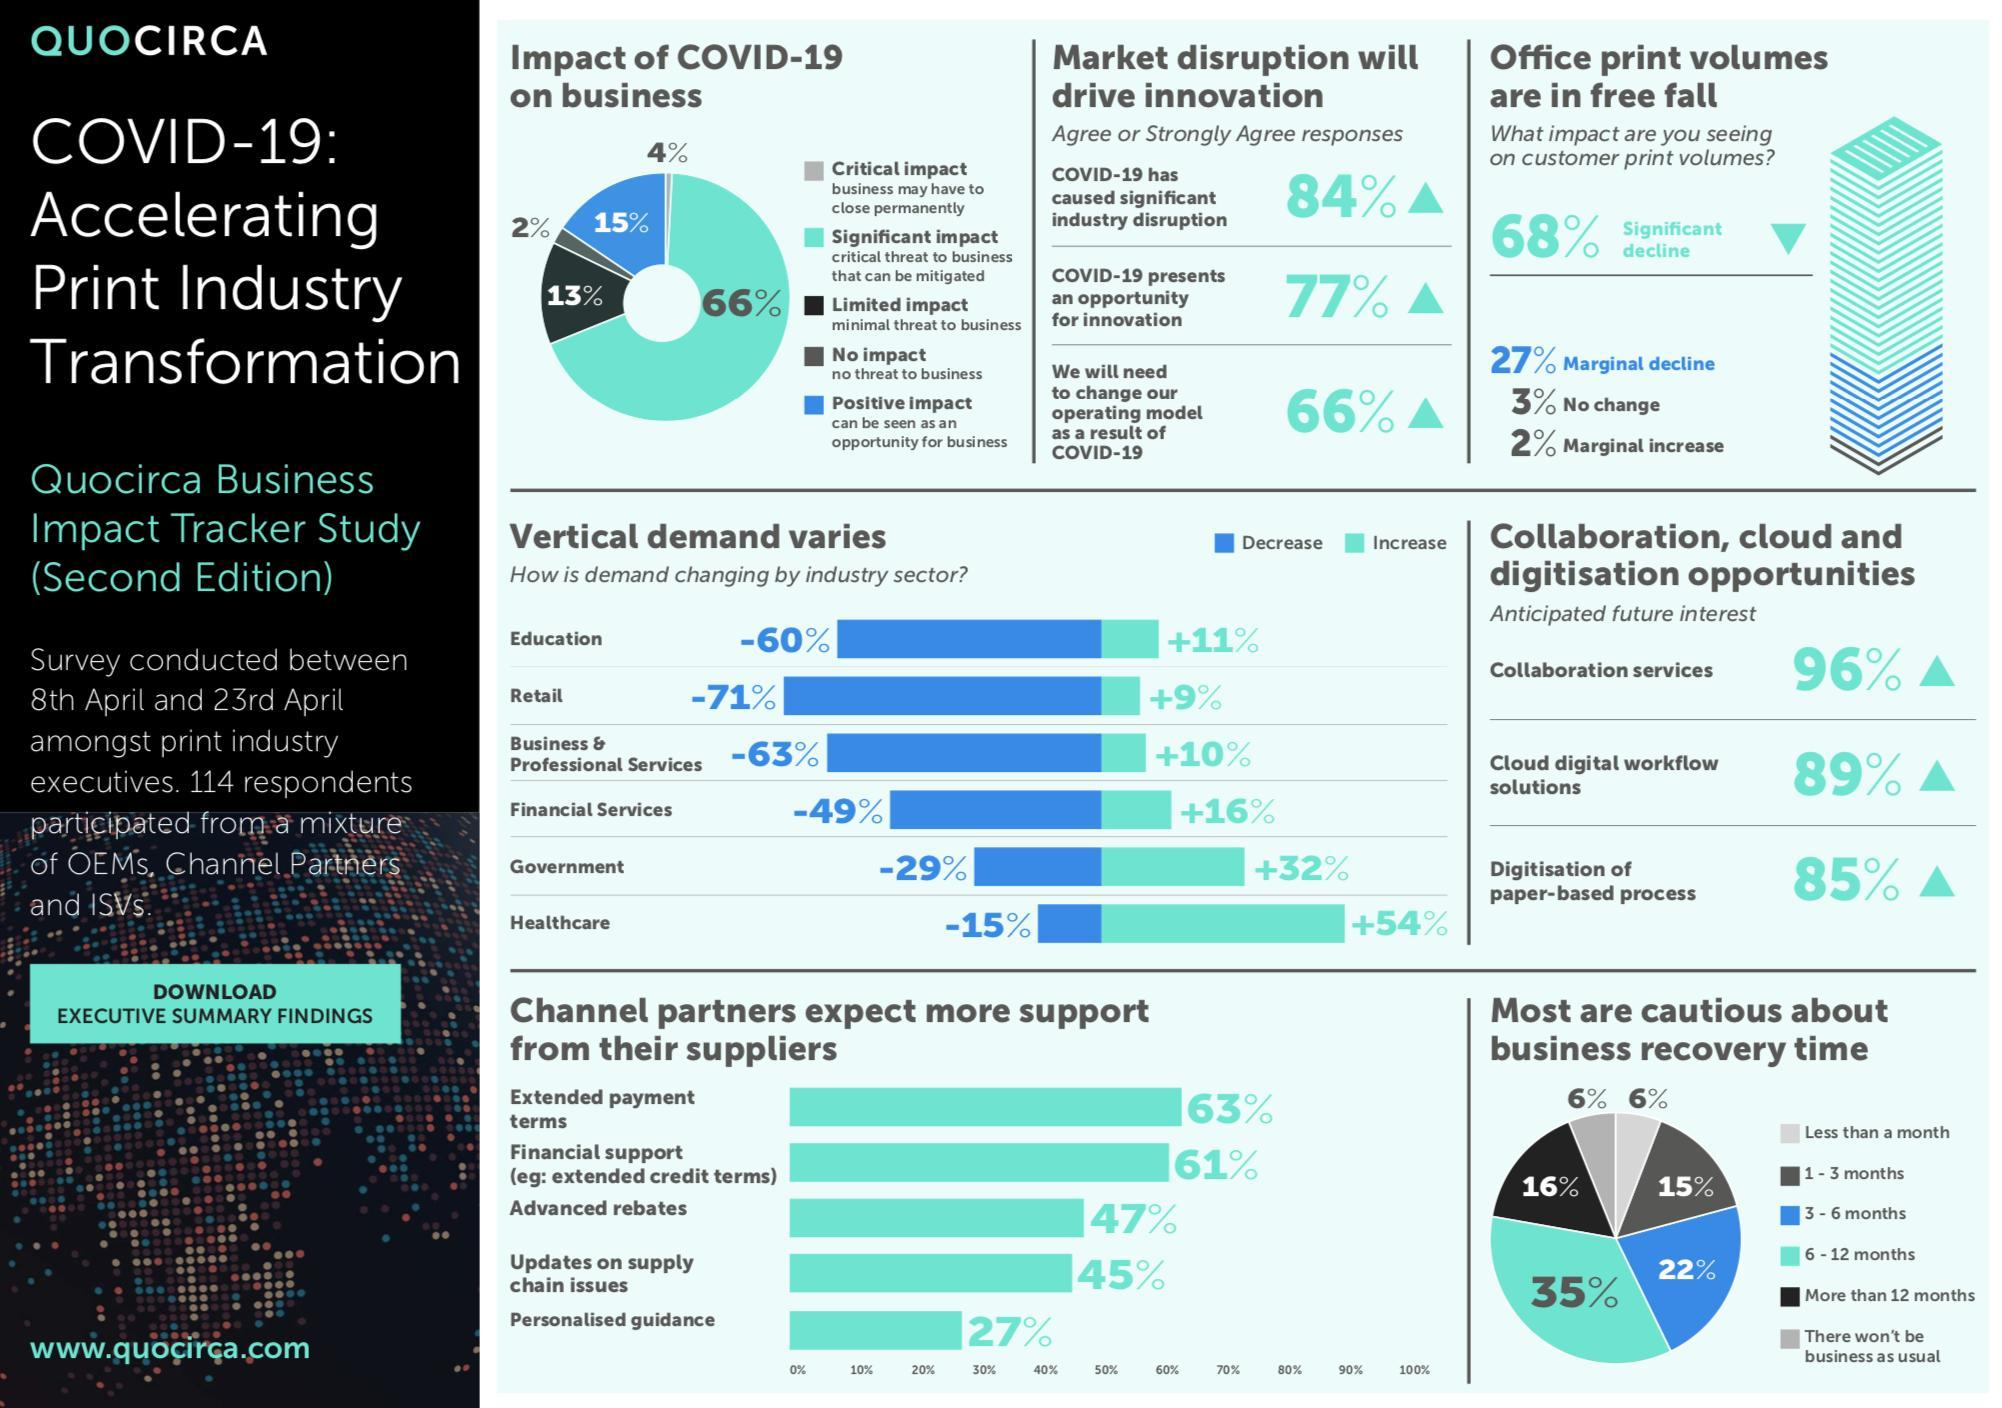What percent of businesses may have to close permanently?
Answer the question with a short phrase. 4% How many of the businesses face minimal threat to business due to COVID-19? 13% What was the impact of COVID-19 on 15% of businesses? Positive impact Which industry sector faces biggest decrease in demand? retail What percent of people think that business will recover in 3-6 months? 22% Which industry sector faces biggest increase in demand? healthcare What percent of businesses see no threat to business? 2% What threat do 66% of businesses face due to impact of COVID-19? critical threat to business that can be mitigated By what percent did demand increase in government sector? 32% How many think that business will recover in 6-12 months? 35% 